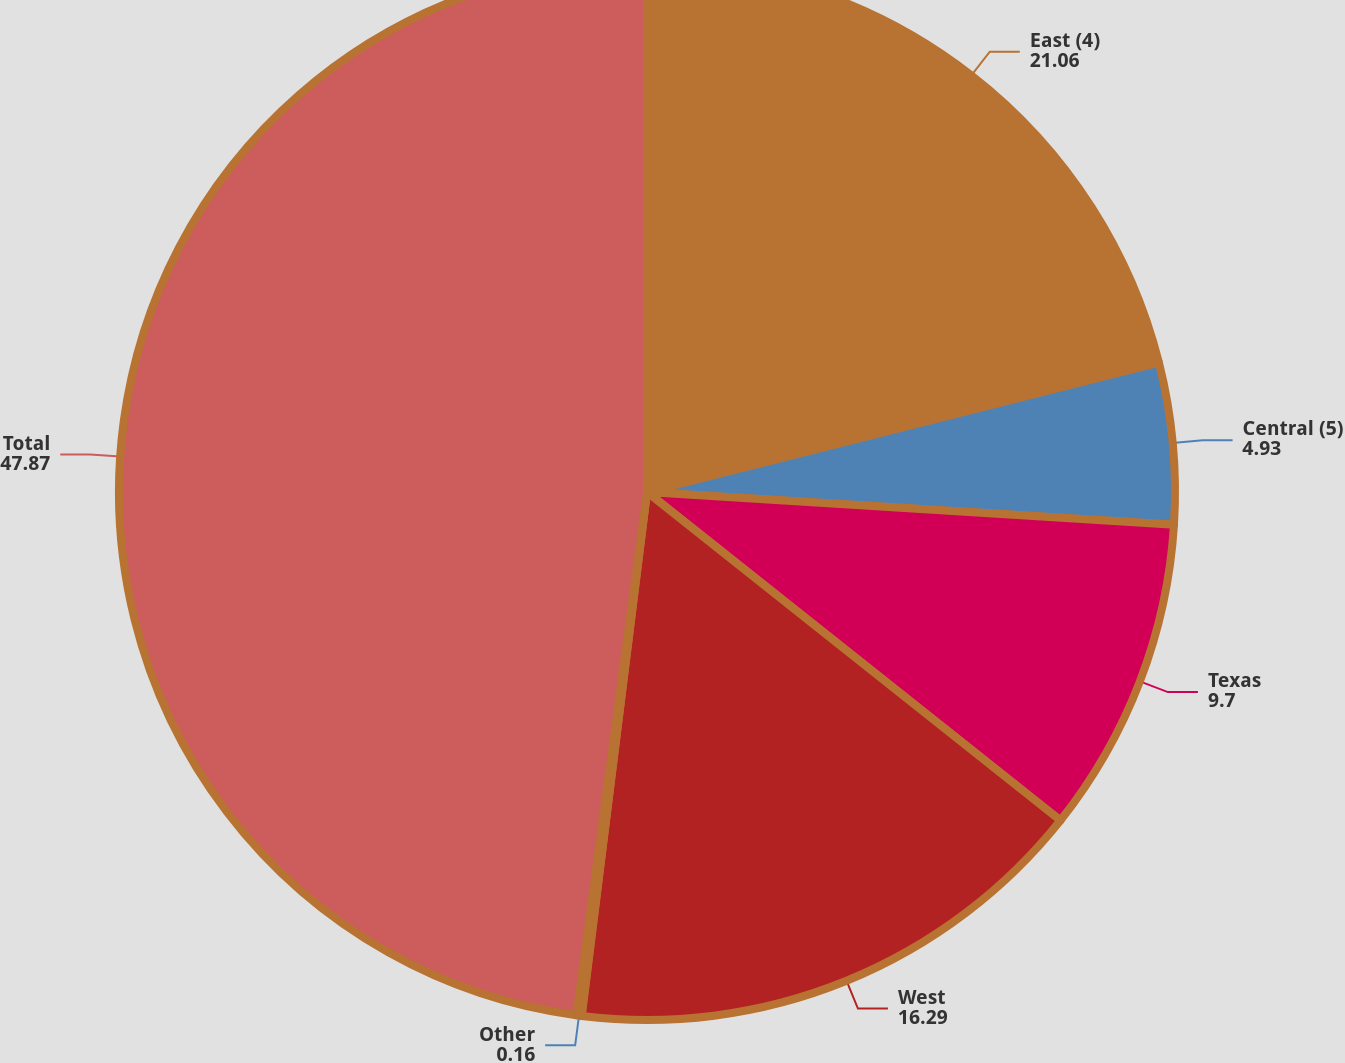Convert chart. <chart><loc_0><loc_0><loc_500><loc_500><pie_chart><fcel>East (4)<fcel>Central (5)<fcel>Texas<fcel>West<fcel>Other<fcel>Total<nl><fcel>21.06%<fcel>4.93%<fcel>9.7%<fcel>16.29%<fcel>0.16%<fcel>47.87%<nl></chart> 